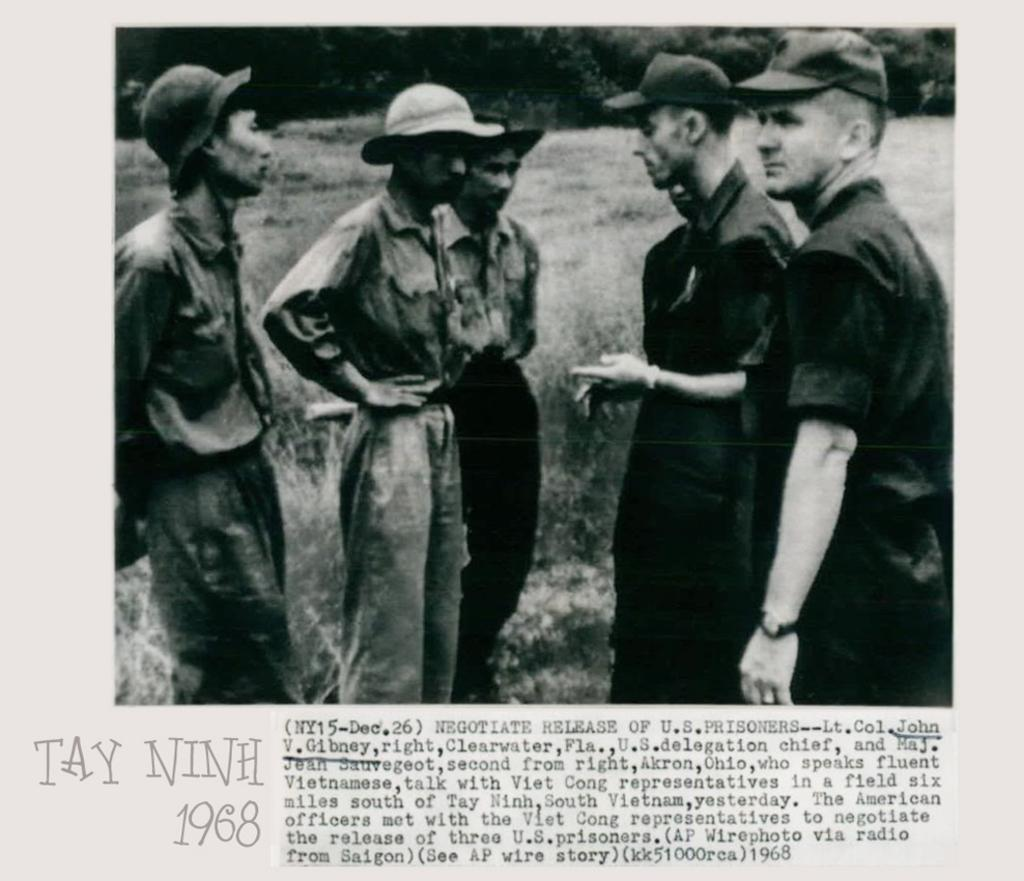What is the main subject of the image? The main subject of the image is a paper. What can be found on the paper? The paper contains pictures of people and text. What are the people in the pictures doing? The people in the pictures are standing. What are the people in the pictures wearing? The people in the pictures are wearing clothes and caps. What type of vegetation is visible in the image? There is grass visible in the image. What else can be seen in the image? There are trees in the image. Where is the oven located in the image? There is no oven present in the image. What type of berry can be seen growing on the trees in the image? There are no berries visible on the trees in the image. 